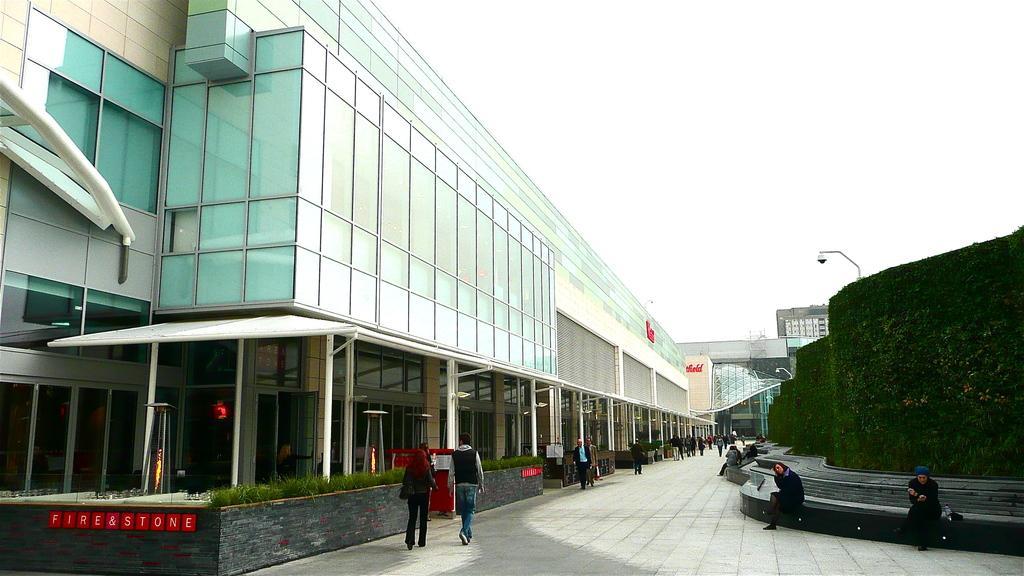Please provide a concise description of this image. In this image we can see some big buildings, one wall full of green plants with steps, some people walking in front of the building, some people are sitting, some objects on the ground, some poles, some text on the glass building, some lights with poles, one whiteboard, some people are holding some objects and at the top there is the sky. 